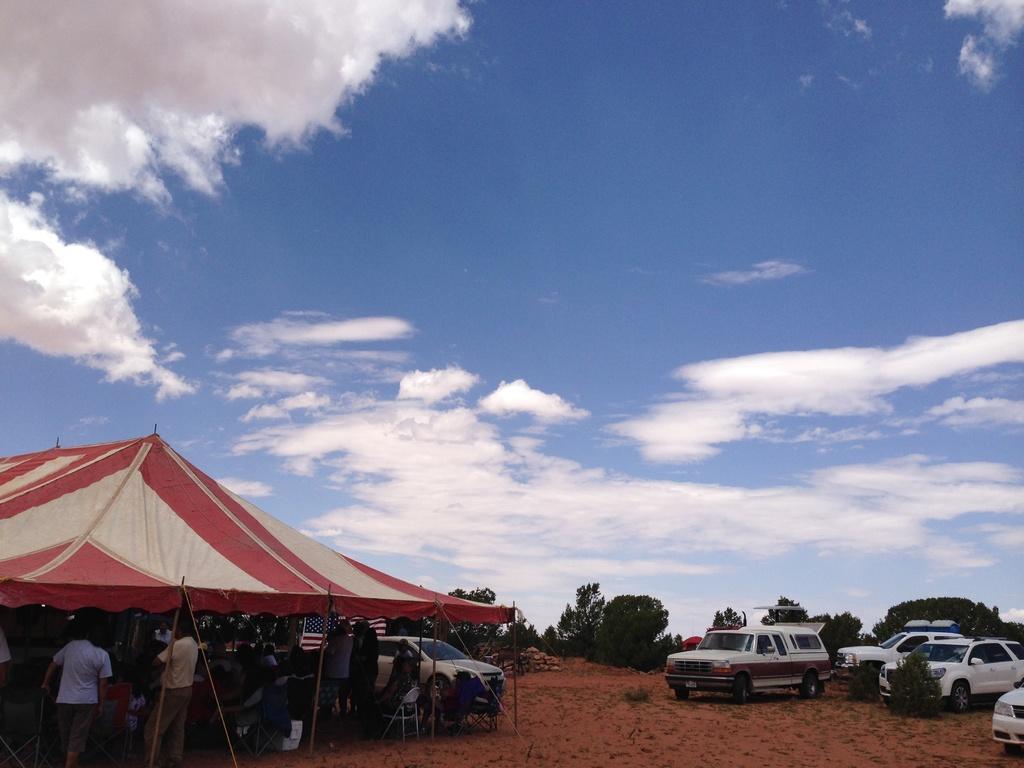How would you summarize this image in a sentence or two? In this image there is a tent on the left side bottom. Under the tent there are so many people who are sitting. On the right side there are few cars parked on the ground. At the top there is the sky. In the background there are trees. 